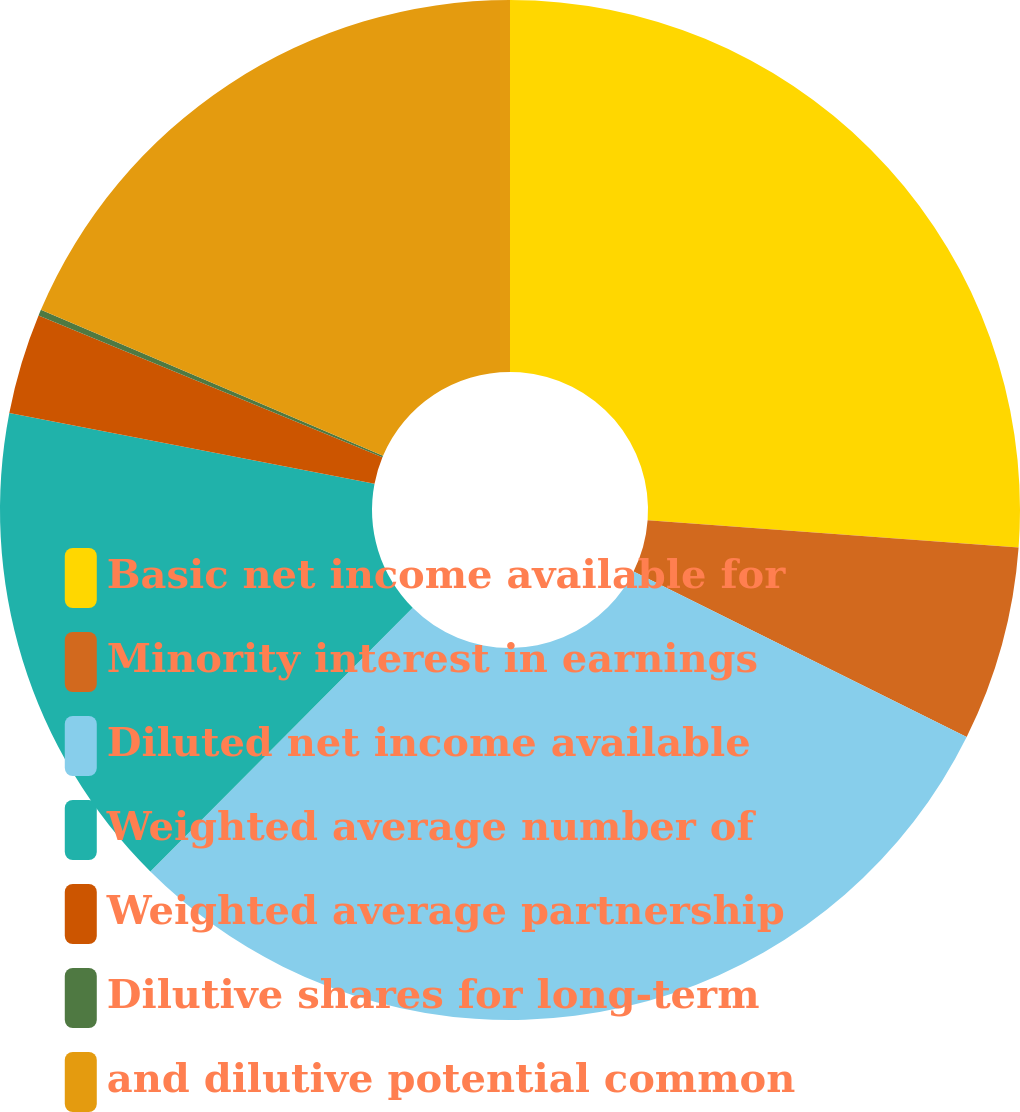Convert chart. <chart><loc_0><loc_0><loc_500><loc_500><pie_chart><fcel>Basic net income available for<fcel>Minority interest in earnings<fcel>Diluted net income available<fcel>Weighted average number of<fcel>Weighted average partnership<fcel>Dilutive shares for long-term<fcel>and dilutive potential common<nl><fcel>26.17%<fcel>6.17%<fcel>30.11%<fcel>15.59%<fcel>3.18%<fcel>0.19%<fcel>18.58%<nl></chart> 